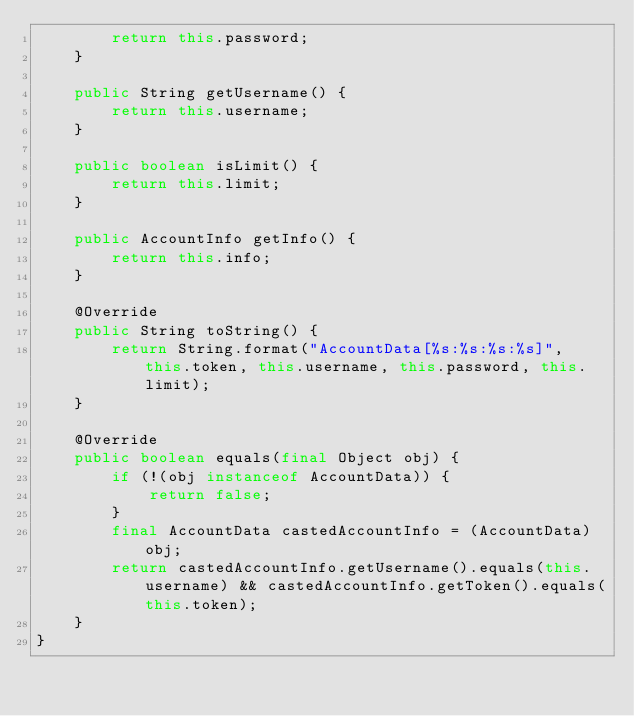<code> <loc_0><loc_0><loc_500><loc_500><_Java_>        return this.password;
    }
    
    public String getUsername() {
        return this.username;
    }
    
    public boolean isLimit() {
        return this.limit;
    }
    
    public AccountInfo getInfo() {
        return this.info;
    }
    
    @Override
    public String toString() {
        return String.format("AccountData[%s:%s:%s:%s]", this.token, this.username, this.password, this.limit);
    }
    
    @Override
    public boolean equals(final Object obj) {
        if (!(obj instanceof AccountData)) {
            return false;
        }
        final AccountData castedAccountInfo = (AccountData)obj;
        return castedAccountInfo.getUsername().equals(this.username) && castedAccountInfo.getToken().equals(this.token);
    }
}
</code> 